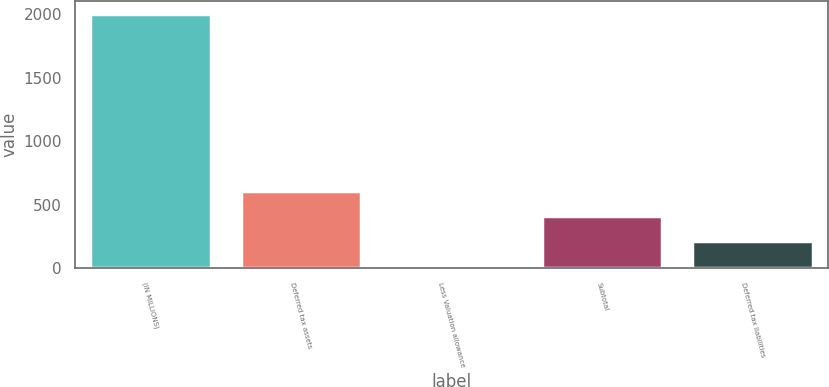Convert chart. <chart><loc_0><loc_0><loc_500><loc_500><bar_chart><fcel>(IN MILLIONS)<fcel>Deferred tax assets<fcel>Less Valuation allowance<fcel>Subtotal<fcel>Deferred tax liabilities<nl><fcel>2004<fcel>611<fcel>14<fcel>412<fcel>213<nl></chart> 